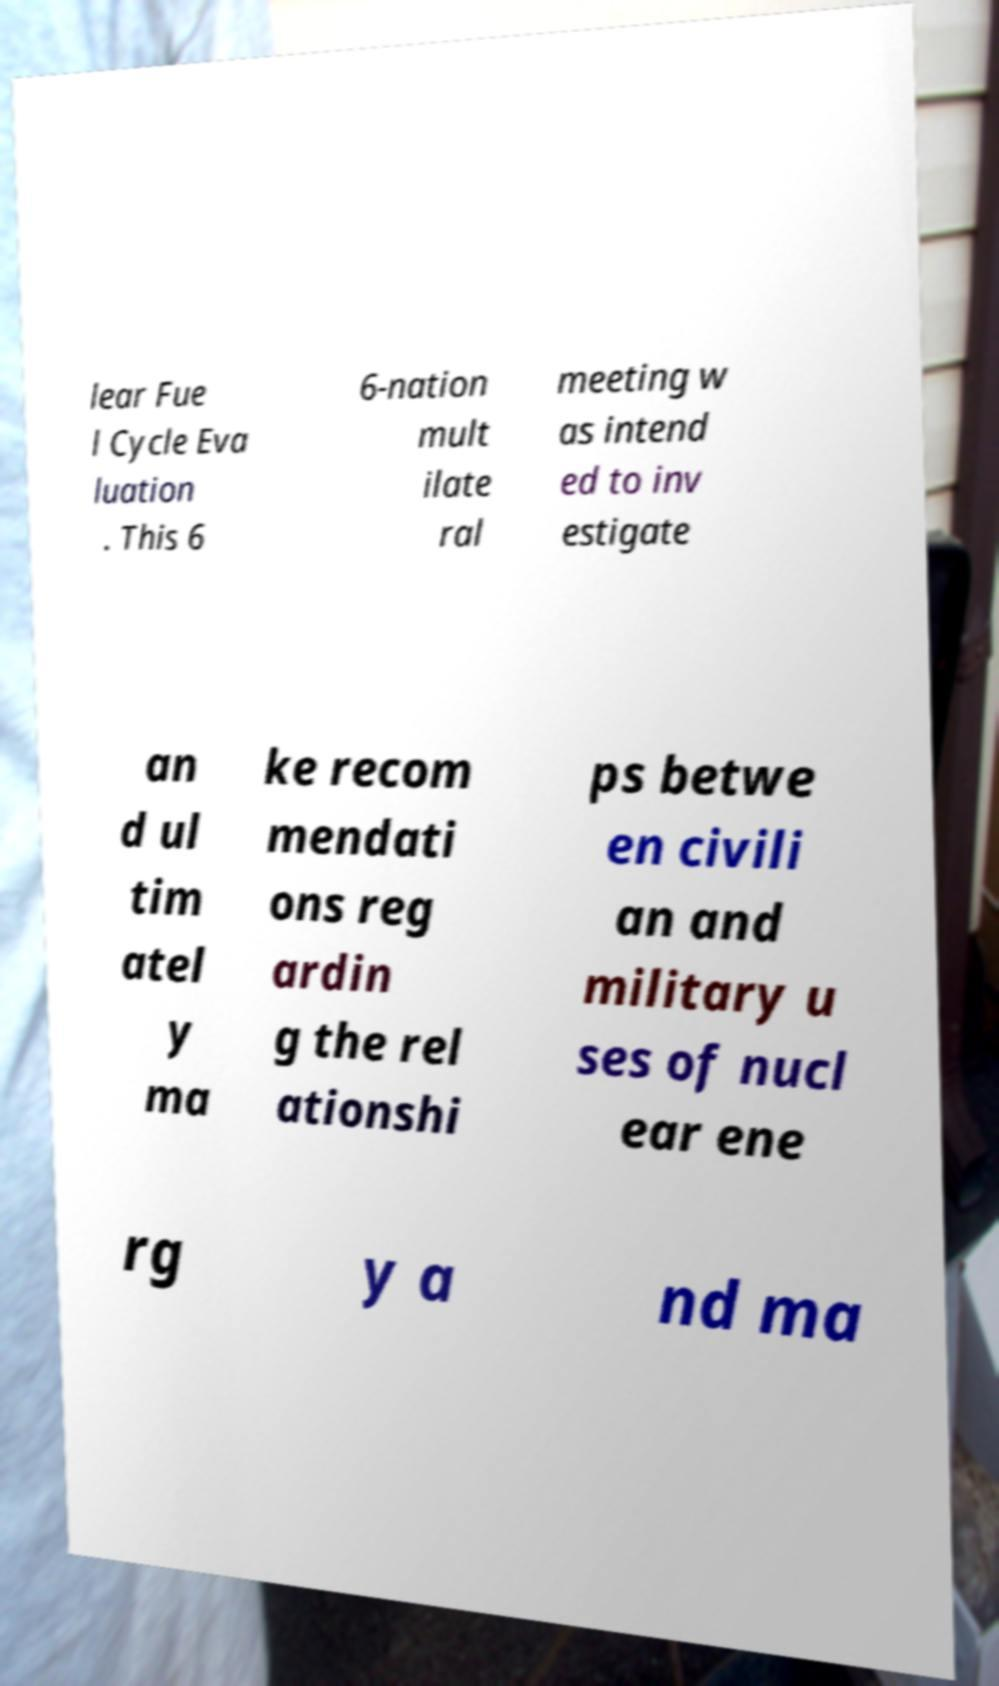Can you read and provide the text displayed in the image?This photo seems to have some interesting text. Can you extract and type it out for me? lear Fue l Cycle Eva luation . This 6 6-nation mult ilate ral meeting w as intend ed to inv estigate an d ul tim atel y ma ke recom mendati ons reg ardin g the rel ationshi ps betwe en civili an and military u ses of nucl ear ene rg y a nd ma 